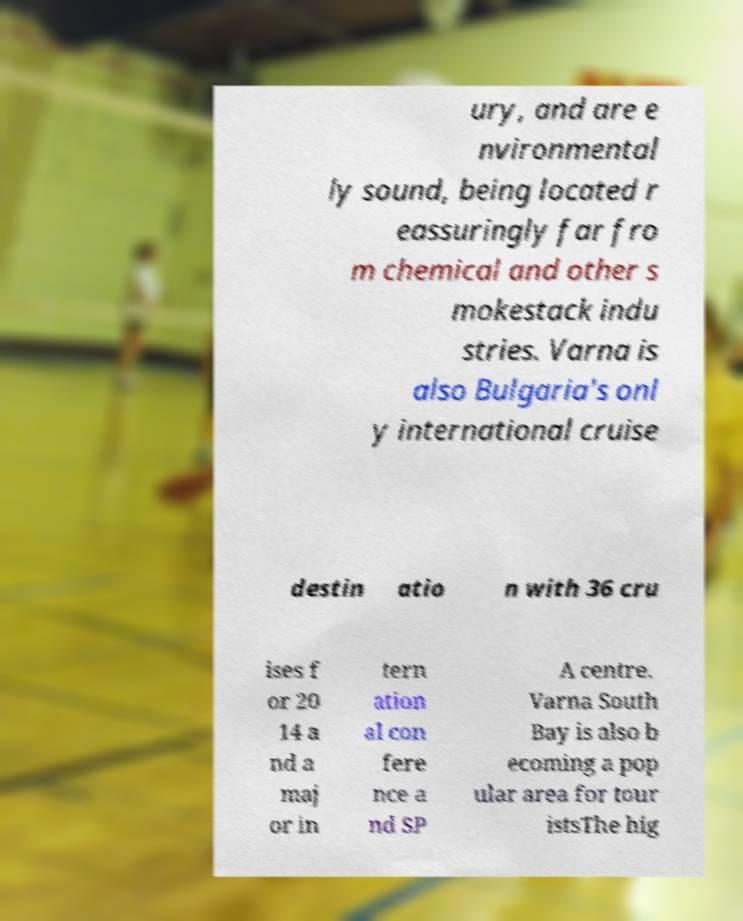There's text embedded in this image that I need extracted. Can you transcribe it verbatim? ury, and are e nvironmental ly sound, being located r eassuringly far fro m chemical and other s mokestack indu stries. Varna is also Bulgaria's onl y international cruise destin atio n with 36 cru ises f or 20 14 a nd a maj or in tern ation al con fere nce a nd SP A centre. Varna South Bay is also b ecoming a pop ular area for tour istsThe hig 